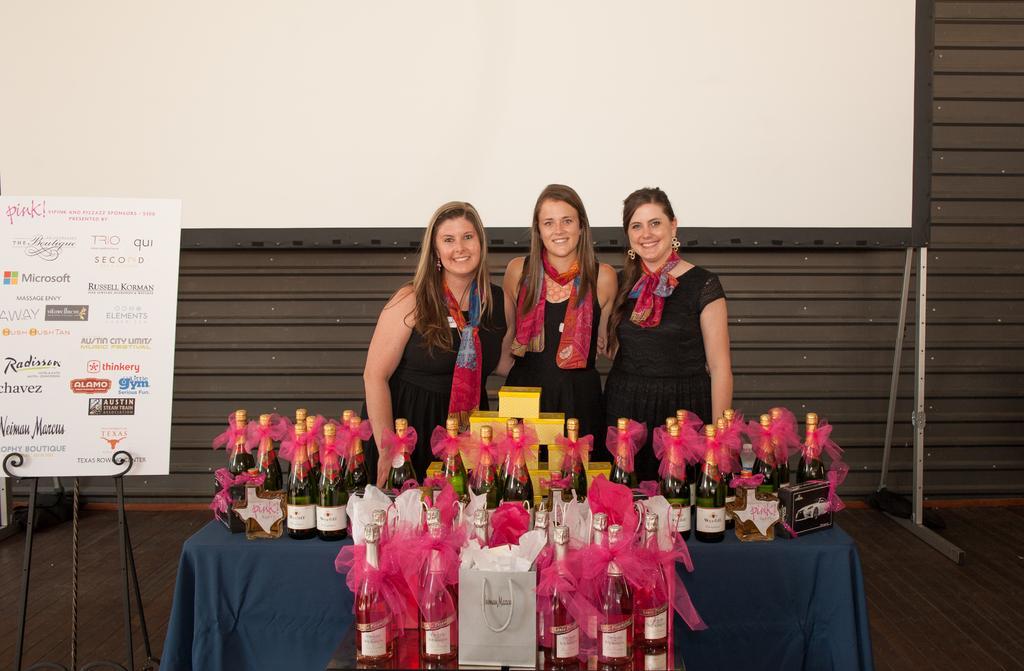In one or two sentences, can you explain what this image depicts? in this picture we can see three ladies standing together we can also see the number of bottles present on the table ,we can also see the board with the text on it. 